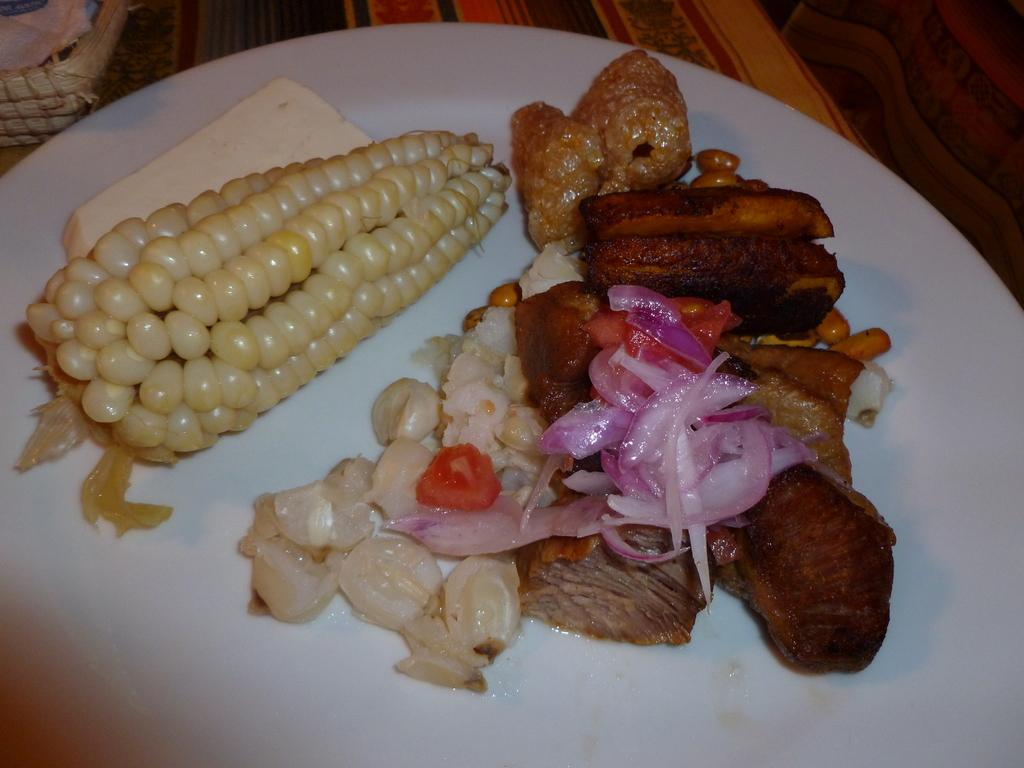What is on the plate in the image? There are food items on a plate in the image. Can you describe anything visible in the background of the image? Unfortunately, the provided facts do not give any specific details about the objects in the background. What discovery was made during the rainstorm in the image? There is no rainstorm present in the image, so it is not possible to answer that question. 